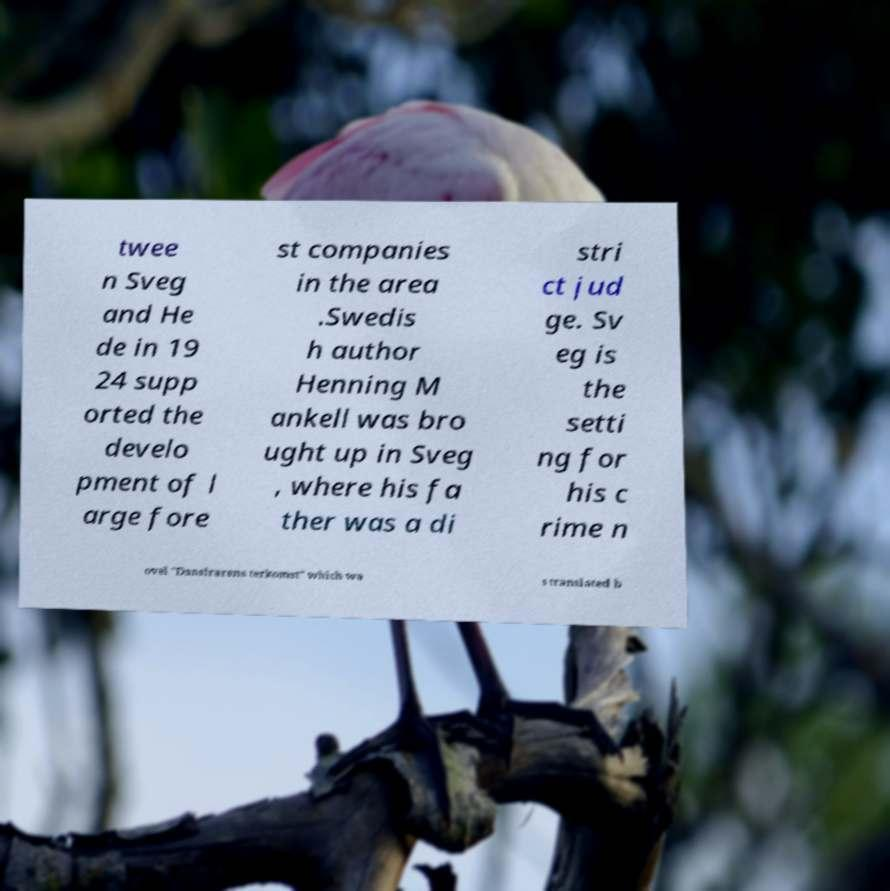What messages or text are displayed in this image? I need them in a readable, typed format. twee n Sveg and He de in 19 24 supp orted the develo pment of l arge fore st companies in the area .Swedis h author Henning M ankell was bro ught up in Sveg , where his fa ther was a di stri ct jud ge. Sv eg is the setti ng for his c rime n ovel "Danslrarens terkomst" which wa s translated b 